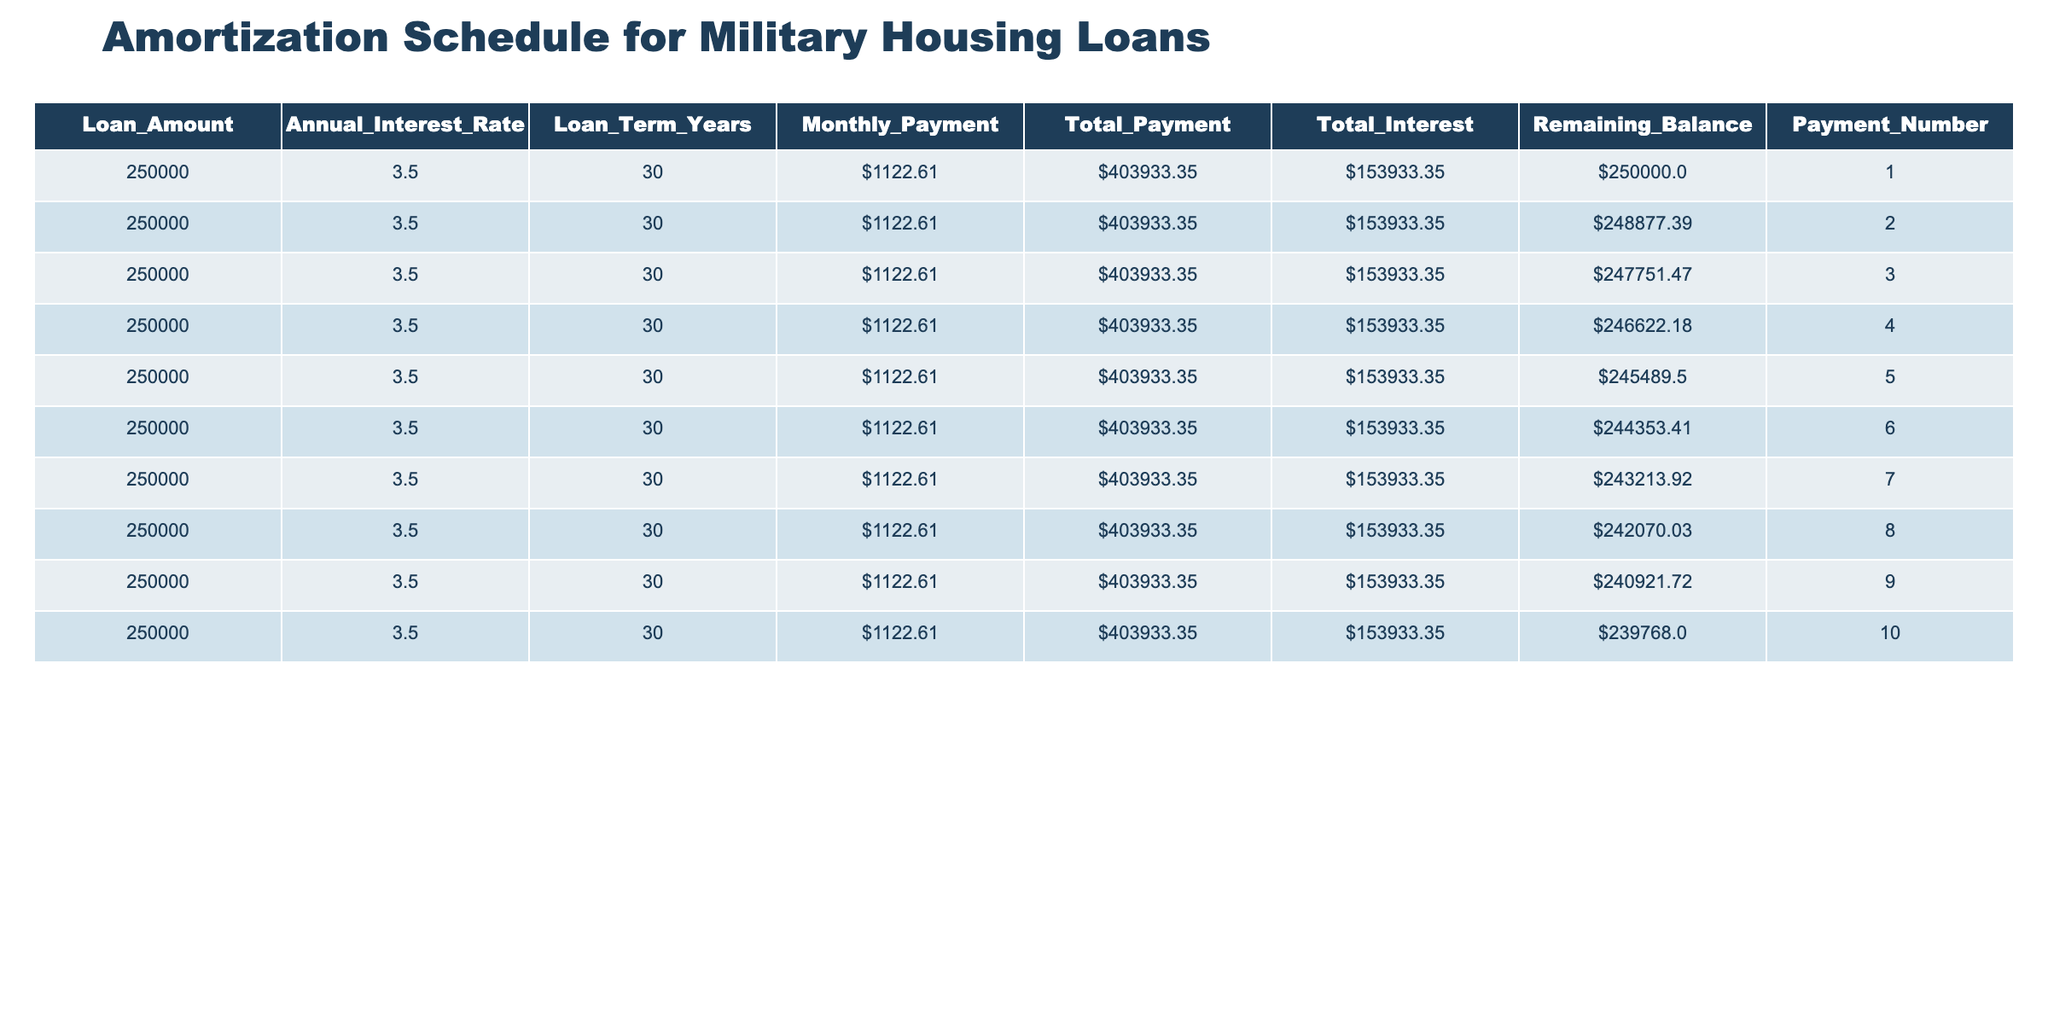What is the monthly payment for the loan? The monthly payment is stated directly in the table under the "Monthly_Payment" column for each row. All entries show a payment of $1,122.61.
Answer: $1,122.61 What is the total amount paid by the end of the loan term? The total payment is located in the "Total_Payment" column for each row. The value is consistent across all entries, indicating that the total payment for the loan is $403,933.35.
Answer: $403,933.35 What is the total interest paid over the loan term? Total interest is listed in the "Total_Interest" column for each entry. This value remains the same across all rows, showing a total interest of $153,933.35 paid over the term.
Answer: $153,933.35 Is the remaining balance after the first payment less than $250,000? By checking the "Remaining_Balance" for the first payment number, we find it is $248,877.39, which is less than $250,000.
Answer: Yes What will the remaining balance be after the 10th payment? The remaining balance after the 10th payment can be found in the "Remaining_Balance" column for payment number 10. The entry shows a remaining balance of $239,768.00.
Answer: $239,768.00 What is the difference in remaining balance between the 1st and the 5th payment? To find the difference, check the "Remaining_Balance" for both the 1st payment ($250,000.00) and the 5th payment ($245,489.50). The difference is calculated as $250,000.00 - $245,489.50 = $5,510.50.
Answer: $5,510.50 What would be the average monthly payment over the first 10 months of the loan? The monthly payment is uniform across the table. Each month's payment is $1,122.61. Thus, the average is the same as the individual payment: $1,122.61.
Answer: $1,122.61 Is the remaining balance after the 7th payment greater than $240,000? The remaining balance after the 7th payment is $243,213.92 as per the table. Since $243,213.92 is greater than $240,000, the statement is true.
Answer: Yes 